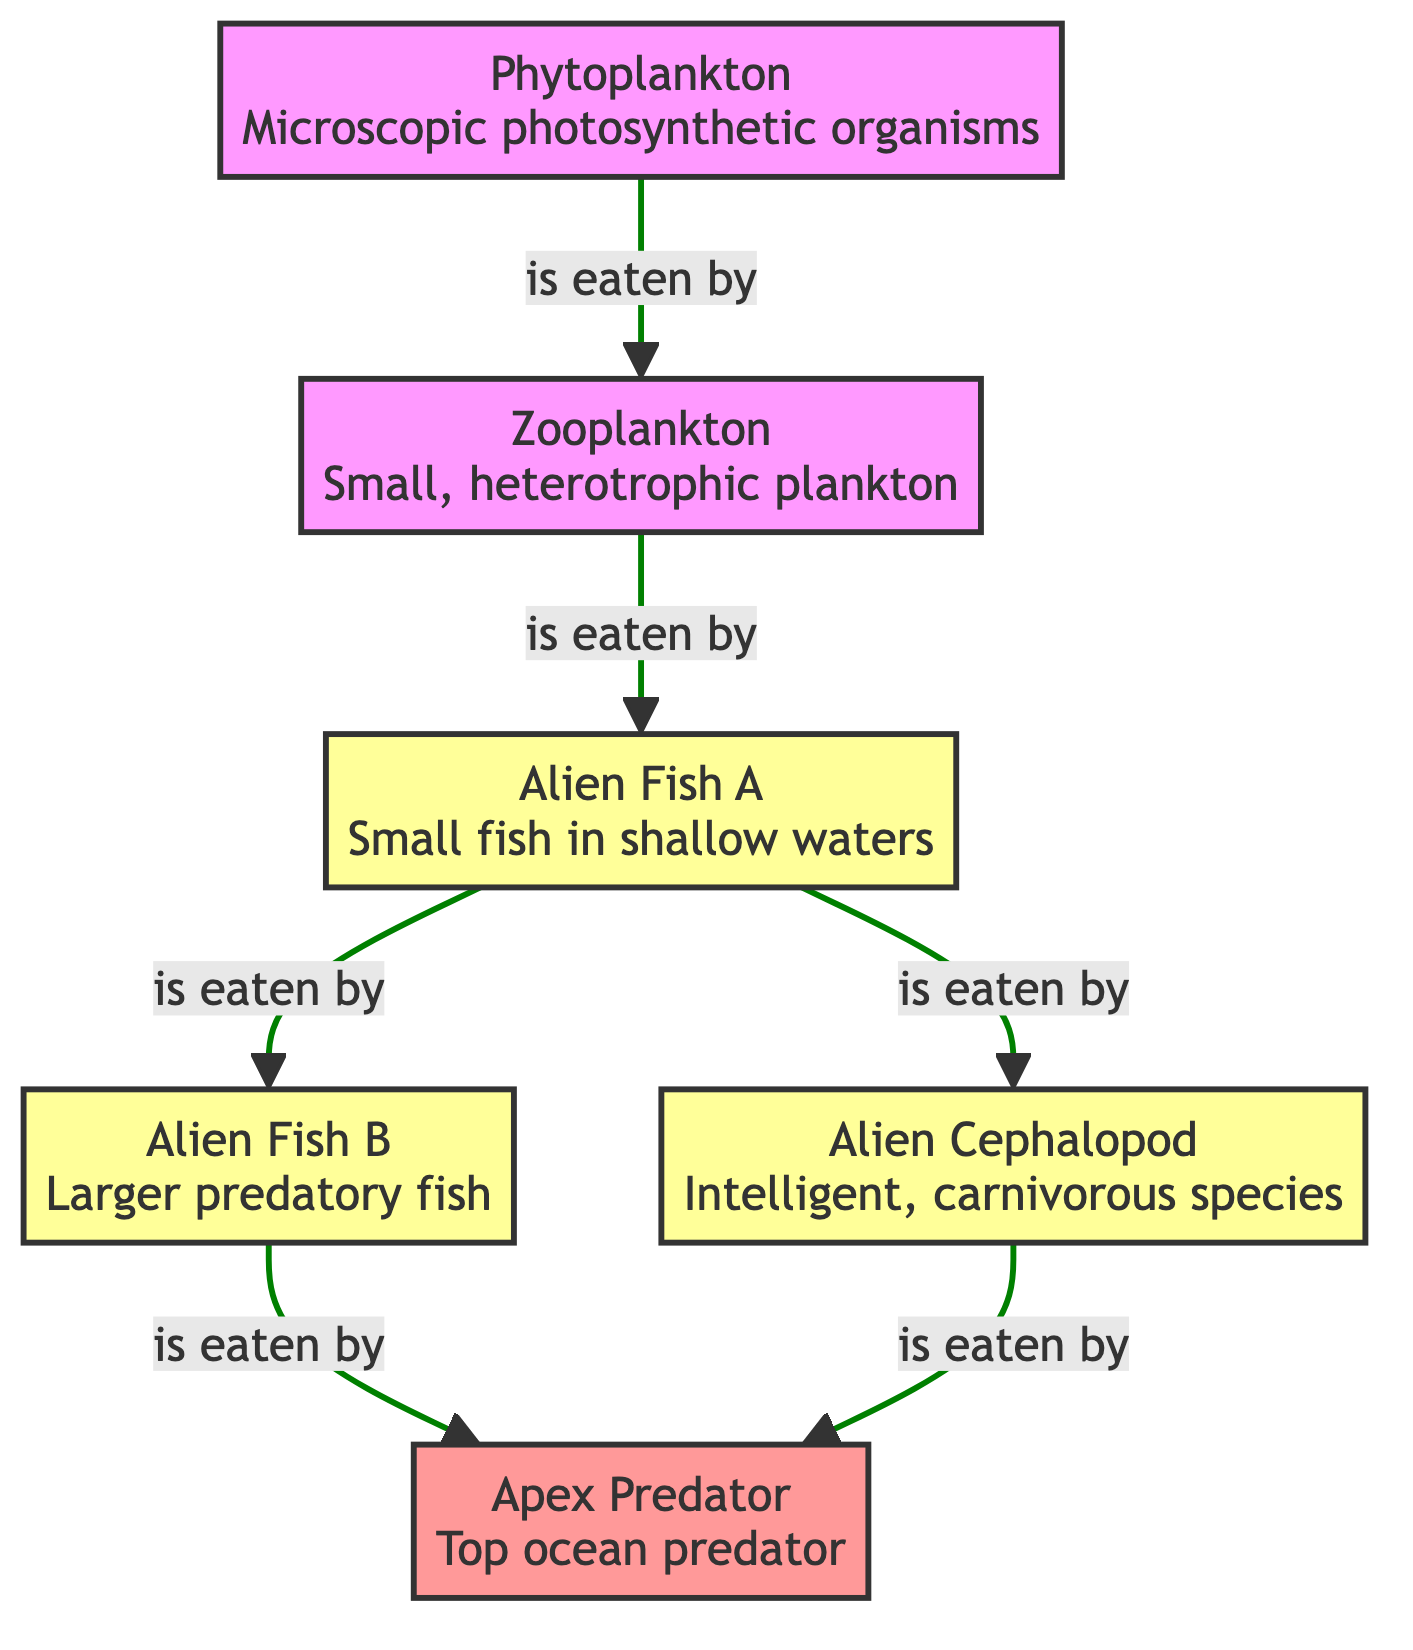What is the primary producer in this ecosystem? In the diagram, the primary producer is represented by the first node, which is the organism that generates energy through photosynthesis. In this case, it is the phytoplankton.
Answer: phytoplankton How many predator species are present in the diagram? By examining the structure of the diagram, the predator nodes are alien fish A, alien fish B, and alien cephalopod. Counting these gives a total of three predator species.
Answer: 3 Which species is the top ocean predator? The apex predator is located at the top of the food chain in the diagram, indicated as the final node that consumes the other predatory species. Therefore, it is the apex predator itself.
Answer: Apex Predator How many edges connect zooplankton to other species? Looking at the diagram, the zooplankton is connected to one other species, which is the alien fish A, indicating a single directional relationship in the food chain.
Answer: 1 Which prey is eaten by alien fish B? In the diagram, alien fish B is connected by an edge to the alien fish A, indicating that alien fish B preys upon alien fish A.
Answer: alien fish A What are the two species that compete for the same prey? By analyzing the flow of nodes that lead away from alien fish A, both alien fish B and alien cephalopod consume alien fish A, indicating that they compete for the same prey species.
Answer: alien fish B and alien cephalopod How many total species are shown in this food chain? Counting all the nodes in the diagram, we have the phytoplankton, zooplankton, two fish species (alien fish A and B), the alien cephalopod, and the apex predator, which totals to six distinct species.
Answer: 6 Which organism is the primary consumer? The primary consumer is the species that feeds directly on the primary producer, which in this case is the zooplankton.
Answer: zooplankton 